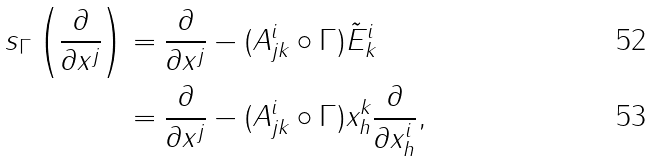Convert formula to latex. <formula><loc_0><loc_0><loc_500><loc_500>s _ { \Gamma } \left ( \frac { \partial } { \partial x ^ { j } } \right ) & = \frac { \partial } { \partial x ^ { j } } - ( A _ { j k } ^ { i } \circ \Gamma ) \tilde { E } _ { k } ^ { i } \\ & = \frac { \partial } { \partial x ^ { j } } - ( A _ { j k } ^ { i } \circ \Gamma ) x _ { h } ^ { k } \frac { \partial } { \partial x _ { h } ^ { i } } ,</formula> 